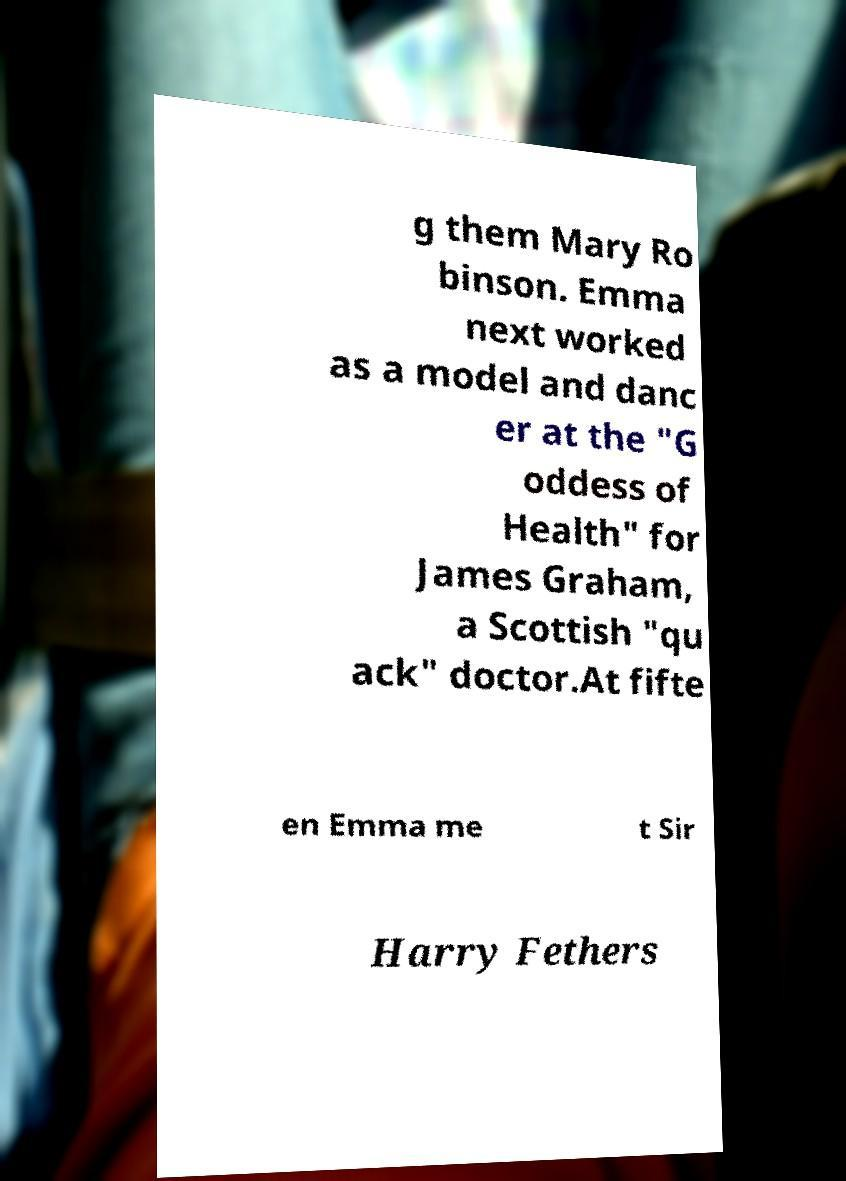Could you extract and type out the text from this image? g them Mary Ro binson. Emma next worked as a model and danc er at the "G oddess of Health" for James Graham, a Scottish "qu ack" doctor.At fifte en Emma me t Sir Harry Fethers 